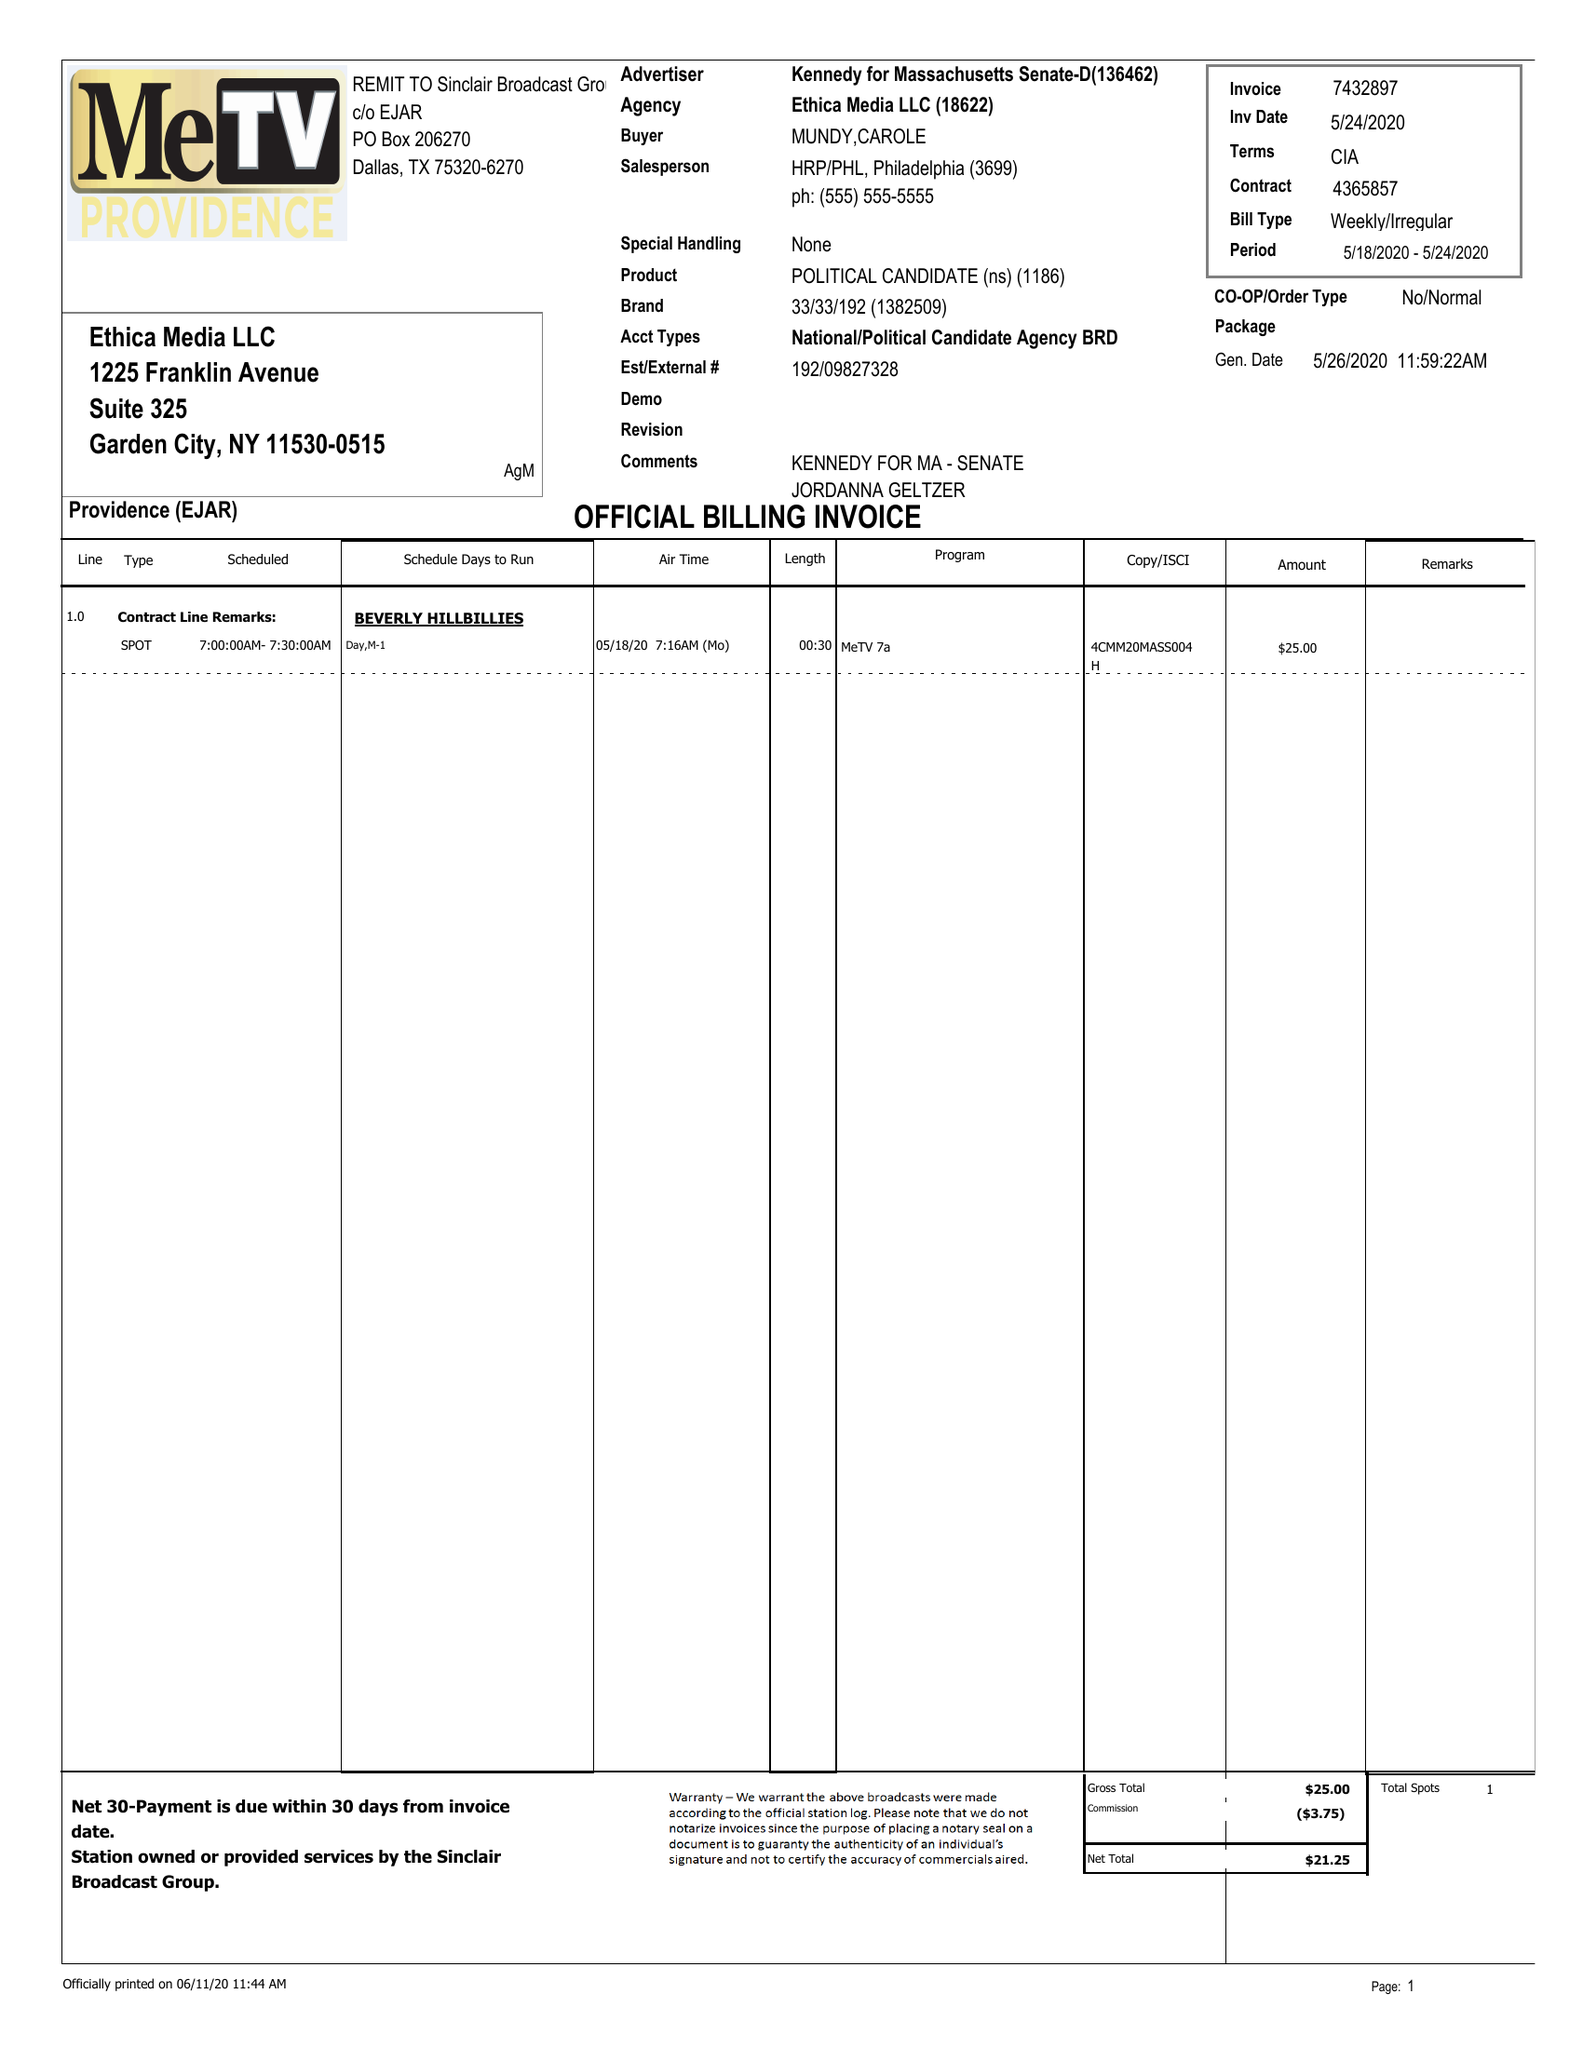What is the value for the flight_to?
Answer the question using a single word or phrase. 05/24/20 